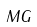<formula> <loc_0><loc_0><loc_500><loc_500>M G</formula> 